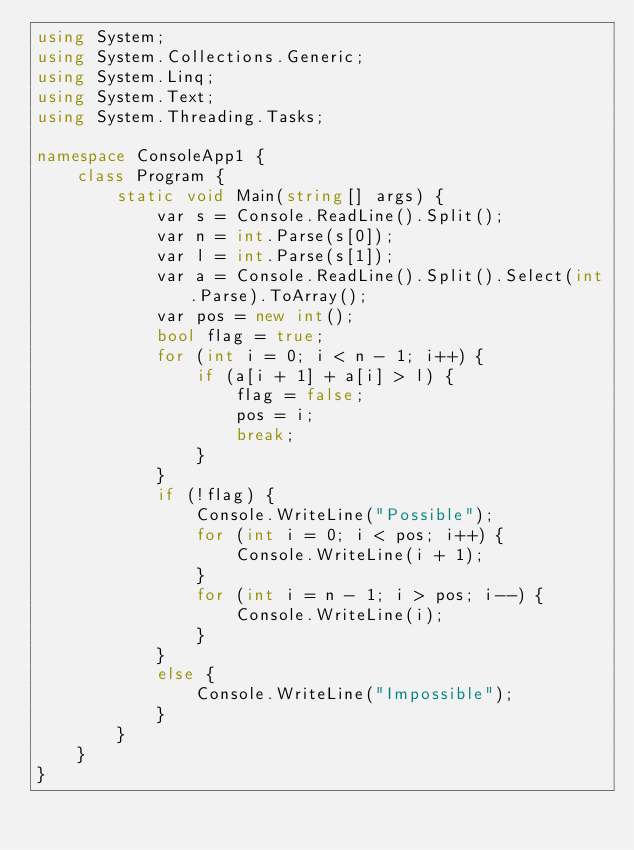<code> <loc_0><loc_0><loc_500><loc_500><_C#_>using System;
using System.Collections.Generic;
using System.Linq;
using System.Text;
using System.Threading.Tasks;

namespace ConsoleApp1 {
    class Program {
        static void Main(string[] args) {
            var s = Console.ReadLine().Split();
            var n = int.Parse(s[0]);
            var l = int.Parse(s[1]);
            var a = Console.ReadLine().Split().Select(int.Parse).ToArray();
            var pos = new int();
            bool flag = true;
            for (int i = 0; i < n - 1; i++) {
                if (a[i + 1] + a[i] > l) {
                    flag = false;
                    pos = i;
                    break;
                }
            }
            if (!flag) {
                Console.WriteLine("Possible");
                for (int i = 0; i < pos; i++) {
                    Console.WriteLine(i + 1);
                }
                for (int i = n - 1; i > pos; i--) {
                    Console.WriteLine(i);
                }
            }
            else {
                Console.WriteLine("Impossible");
            }
        }
    }
}
</code> 